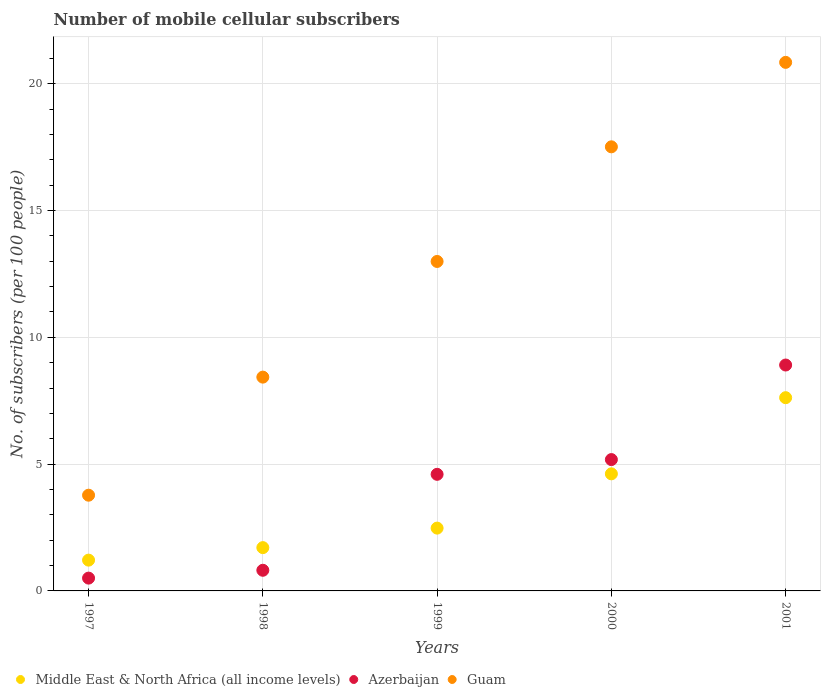How many different coloured dotlines are there?
Give a very brief answer. 3. Is the number of dotlines equal to the number of legend labels?
Provide a short and direct response. Yes. What is the number of mobile cellular subscribers in Guam in 1999?
Your response must be concise. 12.99. Across all years, what is the maximum number of mobile cellular subscribers in Guam?
Provide a succinct answer. 20.84. Across all years, what is the minimum number of mobile cellular subscribers in Azerbaijan?
Your response must be concise. 0.5. In which year was the number of mobile cellular subscribers in Guam maximum?
Provide a short and direct response. 2001. In which year was the number of mobile cellular subscribers in Guam minimum?
Offer a terse response. 1997. What is the total number of mobile cellular subscribers in Azerbaijan in the graph?
Provide a succinct answer. 20. What is the difference between the number of mobile cellular subscribers in Middle East & North Africa (all income levels) in 1997 and that in 2001?
Offer a very short reply. -6.41. What is the difference between the number of mobile cellular subscribers in Azerbaijan in 1998 and the number of mobile cellular subscribers in Middle East & North Africa (all income levels) in 1997?
Offer a very short reply. -0.4. What is the average number of mobile cellular subscribers in Guam per year?
Your response must be concise. 12.71. In the year 2001, what is the difference between the number of mobile cellular subscribers in Azerbaijan and number of mobile cellular subscribers in Middle East & North Africa (all income levels)?
Provide a succinct answer. 1.29. In how many years, is the number of mobile cellular subscribers in Azerbaijan greater than 5?
Give a very brief answer. 2. What is the ratio of the number of mobile cellular subscribers in Azerbaijan in 1997 to that in 2001?
Provide a short and direct response. 0.06. Is the difference between the number of mobile cellular subscribers in Azerbaijan in 1997 and 1998 greater than the difference between the number of mobile cellular subscribers in Middle East & North Africa (all income levels) in 1997 and 1998?
Offer a very short reply. Yes. What is the difference between the highest and the second highest number of mobile cellular subscribers in Guam?
Offer a very short reply. 3.33. What is the difference between the highest and the lowest number of mobile cellular subscribers in Middle East & North Africa (all income levels)?
Your answer should be very brief. 6.41. Is the sum of the number of mobile cellular subscribers in Azerbaijan in 1999 and 2000 greater than the maximum number of mobile cellular subscribers in Guam across all years?
Make the answer very short. No. How many dotlines are there?
Offer a very short reply. 3. How many years are there in the graph?
Your answer should be compact. 5. Does the graph contain grids?
Your answer should be very brief. Yes. Where does the legend appear in the graph?
Make the answer very short. Bottom left. How many legend labels are there?
Your response must be concise. 3. How are the legend labels stacked?
Your answer should be very brief. Horizontal. What is the title of the graph?
Your answer should be very brief. Number of mobile cellular subscribers. Does "Bulgaria" appear as one of the legend labels in the graph?
Give a very brief answer. No. What is the label or title of the Y-axis?
Your answer should be very brief. No. of subscribers (per 100 people). What is the No. of subscribers (per 100 people) of Middle East & North Africa (all income levels) in 1997?
Your answer should be very brief. 1.21. What is the No. of subscribers (per 100 people) of Azerbaijan in 1997?
Offer a terse response. 0.5. What is the No. of subscribers (per 100 people) in Guam in 1997?
Your answer should be very brief. 3.77. What is the No. of subscribers (per 100 people) in Middle East & North Africa (all income levels) in 1998?
Provide a succinct answer. 1.71. What is the No. of subscribers (per 100 people) of Azerbaijan in 1998?
Offer a terse response. 0.81. What is the No. of subscribers (per 100 people) in Guam in 1998?
Provide a succinct answer. 8.43. What is the No. of subscribers (per 100 people) in Middle East & North Africa (all income levels) in 1999?
Give a very brief answer. 2.48. What is the No. of subscribers (per 100 people) of Azerbaijan in 1999?
Your response must be concise. 4.6. What is the No. of subscribers (per 100 people) of Guam in 1999?
Your answer should be compact. 12.99. What is the No. of subscribers (per 100 people) in Middle East & North Africa (all income levels) in 2000?
Make the answer very short. 4.62. What is the No. of subscribers (per 100 people) in Azerbaijan in 2000?
Make the answer very short. 5.18. What is the No. of subscribers (per 100 people) of Guam in 2000?
Give a very brief answer. 17.51. What is the No. of subscribers (per 100 people) in Middle East & North Africa (all income levels) in 2001?
Offer a very short reply. 7.62. What is the No. of subscribers (per 100 people) of Azerbaijan in 2001?
Your response must be concise. 8.91. What is the No. of subscribers (per 100 people) of Guam in 2001?
Your answer should be very brief. 20.84. Across all years, what is the maximum No. of subscribers (per 100 people) of Middle East & North Africa (all income levels)?
Your response must be concise. 7.62. Across all years, what is the maximum No. of subscribers (per 100 people) in Azerbaijan?
Give a very brief answer. 8.91. Across all years, what is the maximum No. of subscribers (per 100 people) in Guam?
Your answer should be compact. 20.84. Across all years, what is the minimum No. of subscribers (per 100 people) of Middle East & North Africa (all income levels)?
Keep it short and to the point. 1.21. Across all years, what is the minimum No. of subscribers (per 100 people) of Azerbaijan?
Offer a terse response. 0.5. Across all years, what is the minimum No. of subscribers (per 100 people) in Guam?
Provide a short and direct response. 3.77. What is the total No. of subscribers (per 100 people) in Middle East & North Africa (all income levels) in the graph?
Ensure brevity in your answer.  17.63. What is the total No. of subscribers (per 100 people) in Azerbaijan in the graph?
Provide a succinct answer. 20. What is the total No. of subscribers (per 100 people) of Guam in the graph?
Ensure brevity in your answer.  63.55. What is the difference between the No. of subscribers (per 100 people) of Middle East & North Africa (all income levels) in 1997 and that in 1998?
Offer a very short reply. -0.49. What is the difference between the No. of subscribers (per 100 people) of Azerbaijan in 1997 and that in 1998?
Your answer should be very brief. -0.31. What is the difference between the No. of subscribers (per 100 people) of Guam in 1997 and that in 1998?
Give a very brief answer. -4.66. What is the difference between the No. of subscribers (per 100 people) of Middle East & North Africa (all income levels) in 1997 and that in 1999?
Offer a terse response. -1.26. What is the difference between the No. of subscribers (per 100 people) in Azerbaijan in 1997 and that in 1999?
Your answer should be compact. -4.09. What is the difference between the No. of subscribers (per 100 people) in Guam in 1997 and that in 1999?
Give a very brief answer. -9.22. What is the difference between the No. of subscribers (per 100 people) in Middle East & North Africa (all income levels) in 1997 and that in 2000?
Your answer should be very brief. -3.4. What is the difference between the No. of subscribers (per 100 people) of Azerbaijan in 1997 and that in 2000?
Give a very brief answer. -4.67. What is the difference between the No. of subscribers (per 100 people) of Guam in 1997 and that in 2000?
Offer a very short reply. -13.74. What is the difference between the No. of subscribers (per 100 people) in Middle East & North Africa (all income levels) in 1997 and that in 2001?
Keep it short and to the point. -6.41. What is the difference between the No. of subscribers (per 100 people) of Azerbaijan in 1997 and that in 2001?
Provide a short and direct response. -8.4. What is the difference between the No. of subscribers (per 100 people) in Guam in 1997 and that in 2001?
Provide a short and direct response. -17.07. What is the difference between the No. of subscribers (per 100 people) of Middle East & North Africa (all income levels) in 1998 and that in 1999?
Provide a short and direct response. -0.77. What is the difference between the No. of subscribers (per 100 people) of Azerbaijan in 1998 and that in 1999?
Give a very brief answer. -3.78. What is the difference between the No. of subscribers (per 100 people) of Guam in 1998 and that in 1999?
Ensure brevity in your answer.  -4.56. What is the difference between the No. of subscribers (per 100 people) in Middle East & North Africa (all income levels) in 1998 and that in 2000?
Give a very brief answer. -2.91. What is the difference between the No. of subscribers (per 100 people) of Azerbaijan in 1998 and that in 2000?
Make the answer very short. -4.36. What is the difference between the No. of subscribers (per 100 people) in Guam in 1998 and that in 2000?
Your answer should be very brief. -9.08. What is the difference between the No. of subscribers (per 100 people) of Middle East & North Africa (all income levels) in 1998 and that in 2001?
Your response must be concise. -5.91. What is the difference between the No. of subscribers (per 100 people) of Azerbaijan in 1998 and that in 2001?
Give a very brief answer. -8.09. What is the difference between the No. of subscribers (per 100 people) of Guam in 1998 and that in 2001?
Provide a succinct answer. -12.41. What is the difference between the No. of subscribers (per 100 people) in Middle East & North Africa (all income levels) in 1999 and that in 2000?
Your answer should be compact. -2.14. What is the difference between the No. of subscribers (per 100 people) of Azerbaijan in 1999 and that in 2000?
Offer a very short reply. -0.58. What is the difference between the No. of subscribers (per 100 people) of Guam in 1999 and that in 2000?
Provide a short and direct response. -4.52. What is the difference between the No. of subscribers (per 100 people) in Middle East & North Africa (all income levels) in 1999 and that in 2001?
Your answer should be very brief. -5.14. What is the difference between the No. of subscribers (per 100 people) of Azerbaijan in 1999 and that in 2001?
Provide a short and direct response. -4.31. What is the difference between the No. of subscribers (per 100 people) of Guam in 1999 and that in 2001?
Keep it short and to the point. -7.85. What is the difference between the No. of subscribers (per 100 people) in Middle East & North Africa (all income levels) in 2000 and that in 2001?
Your response must be concise. -3. What is the difference between the No. of subscribers (per 100 people) in Azerbaijan in 2000 and that in 2001?
Give a very brief answer. -3.73. What is the difference between the No. of subscribers (per 100 people) of Guam in 2000 and that in 2001?
Your response must be concise. -3.33. What is the difference between the No. of subscribers (per 100 people) in Middle East & North Africa (all income levels) in 1997 and the No. of subscribers (per 100 people) in Azerbaijan in 1998?
Your answer should be compact. 0.4. What is the difference between the No. of subscribers (per 100 people) of Middle East & North Africa (all income levels) in 1997 and the No. of subscribers (per 100 people) of Guam in 1998?
Your response must be concise. -7.22. What is the difference between the No. of subscribers (per 100 people) of Azerbaijan in 1997 and the No. of subscribers (per 100 people) of Guam in 1998?
Your answer should be very brief. -7.93. What is the difference between the No. of subscribers (per 100 people) of Middle East & North Africa (all income levels) in 1997 and the No. of subscribers (per 100 people) of Azerbaijan in 1999?
Your response must be concise. -3.38. What is the difference between the No. of subscribers (per 100 people) of Middle East & North Africa (all income levels) in 1997 and the No. of subscribers (per 100 people) of Guam in 1999?
Provide a short and direct response. -11.78. What is the difference between the No. of subscribers (per 100 people) in Azerbaijan in 1997 and the No. of subscribers (per 100 people) in Guam in 1999?
Your answer should be compact. -12.49. What is the difference between the No. of subscribers (per 100 people) of Middle East & North Africa (all income levels) in 1997 and the No. of subscribers (per 100 people) of Azerbaijan in 2000?
Provide a succinct answer. -3.96. What is the difference between the No. of subscribers (per 100 people) in Middle East & North Africa (all income levels) in 1997 and the No. of subscribers (per 100 people) in Guam in 2000?
Ensure brevity in your answer.  -16.3. What is the difference between the No. of subscribers (per 100 people) in Azerbaijan in 1997 and the No. of subscribers (per 100 people) in Guam in 2000?
Keep it short and to the point. -17.01. What is the difference between the No. of subscribers (per 100 people) of Middle East & North Africa (all income levels) in 1997 and the No. of subscribers (per 100 people) of Azerbaijan in 2001?
Your response must be concise. -7.69. What is the difference between the No. of subscribers (per 100 people) of Middle East & North Africa (all income levels) in 1997 and the No. of subscribers (per 100 people) of Guam in 2001?
Provide a succinct answer. -19.63. What is the difference between the No. of subscribers (per 100 people) of Azerbaijan in 1997 and the No. of subscribers (per 100 people) of Guam in 2001?
Give a very brief answer. -20.34. What is the difference between the No. of subscribers (per 100 people) of Middle East & North Africa (all income levels) in 1998 and the No. of subscribers (per 100 people) of Azerbaijan in 1999?
Offer a terse response. -2.89. What is the difference between the No. of subscribers (per 100 people) of Middle East & North Africa (all income levels) in 1998 and the No. of subscribers (per 100 people) of Guam in 1999?
Ensure brevity in your answer.  -11.28. What is the difference between the No. of subscribers (per 100 people) in Azerbaijan in 1998 and the No. of subscribers (per 100 people) in Guam in 1999?
Give a very brief answer. -12.18. What is the difference between the No. of subscribers (per 100 people) of Middle East & North Africa (all income levels) in 1998 and the No. of subscribers (per 100 people) of Azerbaijan in 2000?
Your answer should be very brief. -3.47. What is the difference between the No. of subscribers (per 100 people) in Middle East & North Africa (all income levels) in 1998 and the No. of subscribers (per 100 people) in Guam in 2000?
Offer a very short reply. -15.8. What is the difference between the No. of subscribers (per 100 people) in Azerbaijan in 1998 and the No. of subscribers (per 100 people) in Guam in 2000?
Your response must be concise. -16.7. What is the difference between the No. of subscribers (per 100 people) in Middle East & North Africa (all income levels) in 1998 and the No. of subscribers (per 100 people) in Azerbaijan in 2001?
Make the answer very short. -7.2. What is the difference between the No. of subscribers (per 100 people) in Middle East & North Africa (all income levels) in 1998 and the No. of subscribers (per 100 people) in Guam in 2001?
Your response must be concise. -19.13. What is the difference between the No. of subscribers (per 100 people) of Azerbaijan in 1998 and the No. of subscribers (per 100 people) of Guam in 2001?
Provide a short and direct response. -20.03. What is the difference between the No. of subscribers (per 100 people) in Middle East & North Africa (all income levels) in 1999 and the No. of subscribers (per 100 people) in Azerbaijan in 2000?
Your answer should be compact. -2.7. What is the difference between the No. of subscribers (per 100 people) in Middle East & North Africa (all income levels) in 1999 and the No. of subscribers (per 100 people) in Guam in 2000?
Give a very brief answer. -15.03. What is the difference between the No. of subscribers (per 100 people) of Azerbaijan in 1999 and the No. of subscribers (per 100 people) of Guam in 2000?
Offer a very short reply. -12.91. What is the difference between the No. of subscribers (per 100 people) in Middle East & North Africa (all income levels) in 1999 and the No. of subscribers (per 100 people) in Azerbaijan in 2001?
Keep it short and to the point. -6.43. What is the difference between the No. of subscribers (per 100 people) of Middle East & North Africa (all income levels) in 1999 and the No. of subscribers (per 100 people) of Guam in 2001?
Provide a succinct answer. -18.37. What is the difference between the No. of subscribers (per 100 people) of Azerbaijan in 1999 and the No. of subscribers (per 100 people) of Guam in 2001?
Your answer should be compact. -16.24. What is the difference between the No. of subscribers (per 100 people) of Middle East & North Africa (all income levels) in 2000 and the No. of subscribers (per 100 people) of Azerbaijan in 2001?
Keep it short and to the point. -4.29. What is the difference between the No. of subscribers (per 100 people) in Middle East & North Africa (all income levels) in 2000 and the No. of subscribers (per 100 people) in Guam in 2001?
Your response must be concise. -16.23. What is the difference between the No. of subscribers (per 100 people) in Azerbaijan in 2000 and the No. of subscribers (per 100 people) in Guam in 2001?
Ensure brevity in your answer.  -15.66. What is the average No. of subscribers (per 100 people) of Middle East & North Africa (all income levels) per year?
Offer a very short reply. 3.53. What is the average No. of subscribers (per 100 people) in Azerbaijan per year?
Provide a succinct answer. 4. What is the average No. of subscribers (per 100 people) in Guam per year?
Make the answer very short. 12.71. In the year 1997, what is the difference between the No. of subscribers (per 100 people) in Middle East & North Africa (all income levels) and No. of subscribers (per 100 people) in Azerbaijan?
Offer a very short reply. 0.71. In the year 1997, what is the difference between the No. of subscribers (per 100 people) in Middle East & North Africa (all income levels) and No. of subscribers (per 100 people) in Guam?
Your answer should be very brief. -2.56. In the year 1997, what is the difference between the No. of subscribers (per 100 people) of Azerbaijan and No. of subscribers (per 100 people) of Guam?
Keep it short and to the point. -3.27. In the year 1998, what is the difference between the No. of subscribers (per 100 people) of Middle East & North Africa (all income levels) and No. of subscribers (per 100 people) of Azerbaijan?
Your answer should be compact. 0.89. In the year 1998, what is the difference between the No. of subscribers (per 100 people) in Middle East & North Africa (all income levels) and No. of subscribers (per 100 people) in Guam?
Give a very brief answer. -6.72. In the year 1998, what is the difference between the No. of subscribers (per 100 people) of Azerbaijan and No. of subscribers (per 100 people) of Guam?
Provide a short and direct response. -7.62. In the year 1999, what is the difference between the No. of subscribers (per 100 people) in Middle East & North Africa (all income levels) and No. of subscribers (per 100 people) in Azerbaijan?
Offer a very short reply. -2.12. In the year 1999, what is the difference between the No. of subscribers (per 100 people) of Middle East & North Africa (all income levels) and No. of subscribers (per 100 people) of Guam?
Your answer should be very brief. -10.51. In the year 1999, what is the difference between the No. of subscribers (per 100 people) of Azerbaijan and No. of subscribers (per 100 people) of Guam?
Make the answer very short. -8.39. In the year 2000, what is the difference between the No. of subscribers (per 100 people) in Middle East & North Africa (all income levels) and No. of subscribers (per 100 people) in Azerbaijan?
Ensure brevity in your answer.  -0.56. In the year 2000, what is the difference between the No. of subscribers (per 100 people) of Middle East & North Africa (all income levels) and No. of subscribers (per 100 people) of Guam?
Your response must be concise. -12.89. In the year 2000, what is the difference between the No. of subscribers (per 100 people) of Azerbaijan and No. of subscribers (per 100 people) of Guam?
Provide a short and direct response. -12.33. In the year 2001, what is the difference between the No. of subscribers (per 100 people) of Middle East & North Africa (all income levels) and No. of subscribers (per 100 people) of Azerbaijan?
Make the answer very short. -1.29. In the year 2001, what is the difference between the No. of subscribers (per 100 people) of Middle East & North Africa (all income levels) and No. of subscribers (per 100 people) of Guam?
Give a very brief answer. -13.22. In the year 2001, what is the difference between the No. of subscribers (per 100 people) in Azerbaijan and No. of subscribers (per 100 people) in Guam?
Your answer should be compact. -11.93. What is the ratio of the No. of subscribers (per 100 people) in Middle East & North Africa (all income levels) in 1997 to that in 1998?
Make the answer very short. 0.71. What is the ratio of the No. of subscribers (per 100 people) in Azerbaijan in 1997 to that in 1998?
Offer a terse response. 0.62. What is the ratio of the No. of subscribers (per 100 people) of Guam in 1997 to that in 1998?
Offer a terse response. 0.45. What is the ratio of the No. of subscribers (per 100 people) of Middle East & North Africa (all income levels) in 1997 to that in 1999?
Your answer should be compact. 0.49. What is the ratio of the No. of subscribers (per 100 people) in Azerbaijan in 1997 to that in 1999?
Make the answer very short. 0.11. What is the ratio of the No. of subscribers (per 100 people) in Guam in 1997 to that in 1999?
Your response must be concise. 0.29. What is the ratio of the No. of subscribers (per 100 people) of Middle East & North Africa (all income levels) in 1997 to that in 2000?
Your answer should be very brief. 0.26. What is the ratio of the No. of subscribers (per 100 people) in Azerbaijan in 1997 to that in 2000?
Keep it short and to the point. 0.1. What is the ratio of the No. of subscribers (per 100 people) in Guam in 1997 to that in 2000?
Your answer should be very brief. 0.22. What is the ratio of the No. of subscribers (per 100 people) of Middle East & North Africa (all income levels) in 1997 to that in 2001?
Your response must be concise. 0.16. What is the ratio of the No. of subscribers (per 100 people) in Azerbaijan in 1997 to that in 2001?
Offer a terse response. 0.06. What is the ratio of the No. of subscribers (per 100 people) in Guam in 1997 to that in 2001?
Give a very brief answer. 0.18. What is the ratio of the No. of subscribers (per 100 people) in Middle East & North Africa (all income levels) in 1998 to that in 1999?
Provide a short and direct response. 0.69. What is the ratio of the No. of subscribers (per 100 people) in Azerbaijan in 1998 to that in 1999?
Ensure brevity in your answer.  0.18. What is the ratio of the No. of subscribers (per 100 people) in Guam in 1998 to that in 1999?
Offer a very short reply. 0.65. What is the ratio of the No. of subscribers (per 100 people) in Middle East & North Africa (all income levels) in 1998 to that in 2000?
Give a very brief answer. 0.37. What is the ratio of the No. of subscribers (per 100 people) of Azerbaijan in 1998 to that in 2000?
Make the answer very short. 0.16. What is the ratio of the No. of subscribers (per 100 people) in Guam in 1998 to that in 2000?
Make the answer very short. 0.48. What is the ratio of the No. of subscribers (per 100 people) of Middle East & North Africa (all income levels) in 1998 to that in 2001?
Provide a succinct answer. 0.22. What is the ratio of the No. of subscribers (per 100 people) of Azerbaijan in 1998 to that in 2001?
Your answer should be very brief. 0.09. What is the ratio of the No. of subscribers (per 100 people) in Guam in 1998 to that in 2001?
Ensure brevity in your answer.  0.4. What is the ratio of the No. of subscribers (per 100 people) of Middle East & North Africa (all income levels) in 1999 to that in 2000?
Make the answer very short. 0.54. What is the ratio of the No. of subscribers (per 100 people) in Azerbaijan in 1999 to that in 2000?
Offer a very short reply. 0.89. What is the ratio of the No. of subscribers (per 100 people) of Guam in 1999 to that in 2000?
Keep it short and to the point. 0.74. What is the ratio of the No. of subscribers (per 100 people) of Middle East & North Africa (all income levels) in 1999 to that in 2001?
Give a very brief answer. 0.33. What is the ratio of the No. of subscribers (per 100 people) in Azerbaijan in 1999 to that in 2001?
Provide a short and direct response. 0.52. What is the ratio of the No. of subscribers (per 100 people) in Guam in 1999 to that in 2001?
Your answer should be compact. 0.62. What is the ratio of the No. of subscribers (per 100 people) of Middle East & North Africa (all income levels) in 2000 to that in 2001?
Provide a succinct answer. 0.61. What is the ratio of the No. of subscribers (per 100 people) in Azerbaijan in 2000 to that in 2001?
Offer a very short reply. 0.58. What is the ratio of the No. of subscribers (per 100 people) of Guam in 2000 to that in 2001?
Offer a terse response. 0.84. What is the difference between the highest and the second highest No. of subscribers (per 100 people) of Middle East & North Africa (all income levels)?
Provide a short and direct response. 3. What is the difference between the highest and the second highest No. of subscribers (per 100 people) of Azerbaijan?
Offer a terse response. 3.73. What is the difference between the highest and the second highest No. of subscribers (per 100 people) of Guam?
Provide a succinct answer. 3.33. What is the difference between the highest and the lowest No. of subscribers (per 100 people) in Middle East & North Africa (all income levels)?
Keep it short and to the point. 6.41. What is the difference between the highest and the lowest No. of subscribers (per 100 people) of Azerbaijan?
Ensure brevity in your answer.  8.4. What is the difference between the highest and the lowest No. of subscribers (per 100 people) of Guam?
Keep it short and to the point. 17.07. 